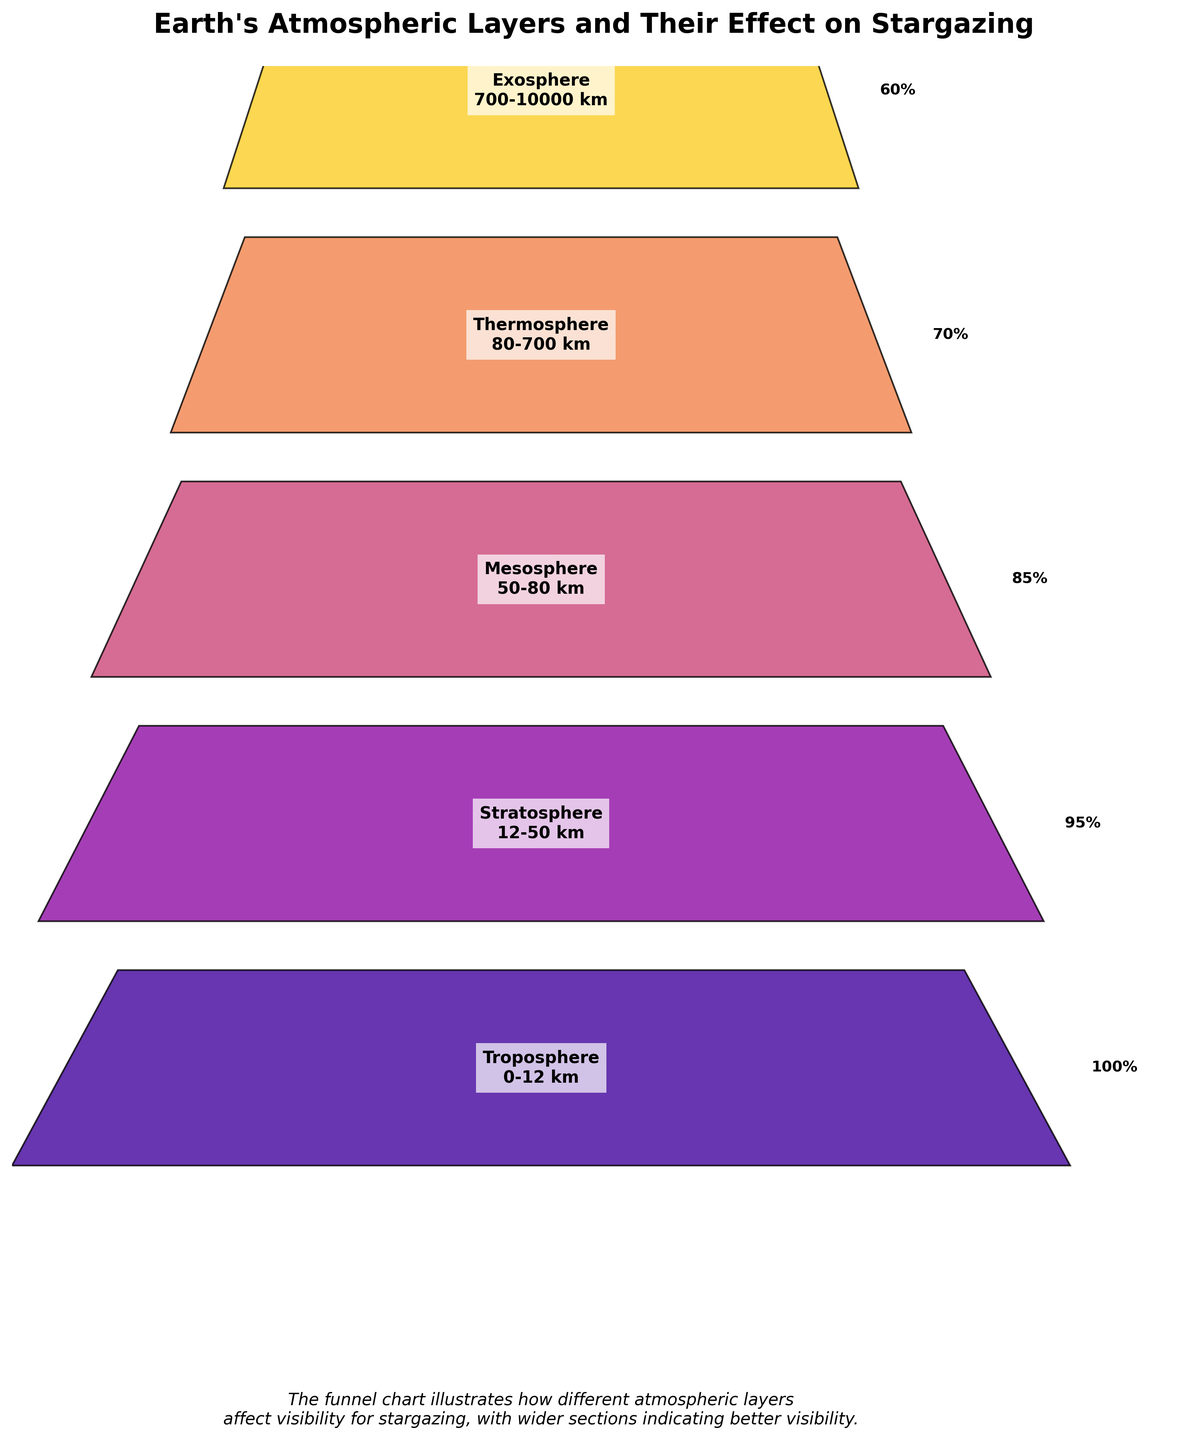What is the title of the figure? The title is usually placed at the top of the figure and gives a general overview of what the chart is about.
Answer: Earth's Atmospheric Layers and Their Effect on Stargazing How many layers of the Earth's atmosphere are represented in the figure? Count the number of distinct layers mentioned in the figure.
Answer: 5 Which layer of the atmosphere has the highest visibility effect for stargazing? Locate the layer with the widest section at the top of the funnel, representing the highest visibility percentage.
Answer: Troposphere What is the visibility effect percentage in the thermosphere? Identify the thermosphere in the chart and look at its corresponding visibility effect percentage.
Answer: 70% What is the total elevation range covered by the figure? Calculate the range by subtracting the starting elevation of the Troposphere (0 km) from the ending elevation of the Exosphere (10000 km).
Answer: 10000 km How does the visibility effect change from the Mesosphere to the Exosphere? Identify the visibility percentages for the Mesosphere and Exosphere, then compare them to see the change.
Answer: It decreases from 85% to 60% If you combine the visibility effects of the Stratosphere and Mesosphere, what percentage do you get? Add the visibility percentages of the Stratosphere (95%) and Mesosphere (85%).
Answer: 180% Which layer shows the least impact on stargazing based on visibility effect percentage? Find the layer with the smallest visibility effect percentage.
Answer: Exosphere Compare the visibility effect in the Stratosphere and Thermosphere. Which one is higher and by how much? Determine the visibility percentages of the Stratosphere and Thermosphere and find the difference.
Answer: Stratosphere is higher by 25% Why might layers lower in the Earth's atmosphere have higher visibility effects for stargazing? Reason about factors affecting visibility, such as atmospheric density and turbulence, which are more pronounced in lower layers like the Troposphere affecting visibility.
Answer: Lower layers like the Troposphere are denser and have more atmospheric turbulence impacting visibility 